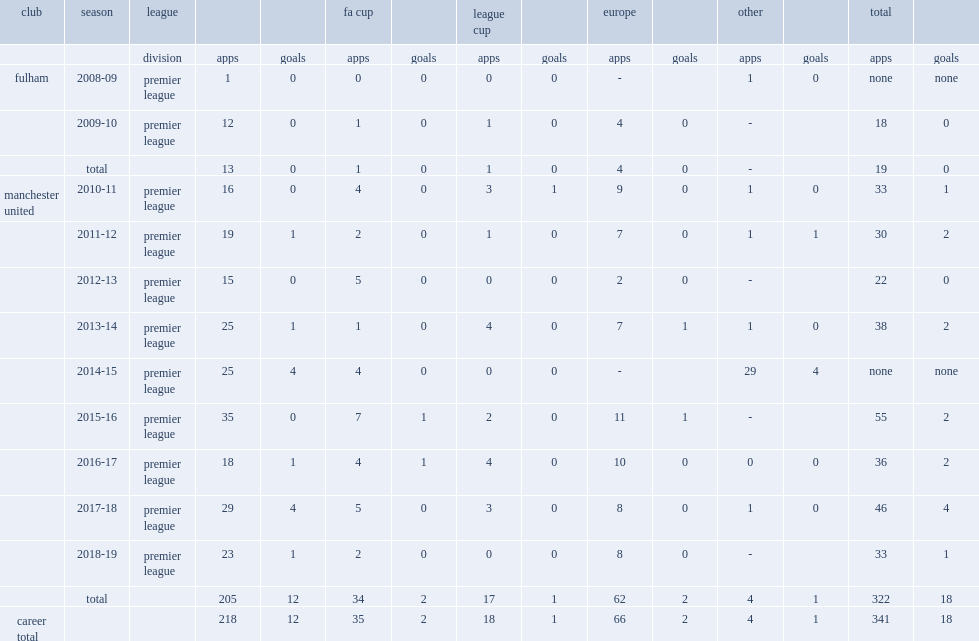Write the full table. {'header': ['club', 'season', 'league', '', '', 'fa cup', '', 'league cup', '', 'europe', '', 'other', '', 'total', ''], 'rows': [['', '', 'division', 'apps', 'goals', 'apps', 'goals', 'apps', 'goals', 'apps', 'goals', 'apps', 'goals', 'apps', 'goals'], ['fulham', '2008-09', 'premier league', '1', '0', '0', '0', '0', '0', '-', '', '1', '0', 'none', 'none'], ['', '2009-10', 'premier league', '12', '0', '1', '0', '1', '0', '4', '0', '-', '', '18', '0'], ['', 'total', '', '13', '0', '1', '0', '1', '0', '4', '0', '-', '', '19', '0'], ['manchester united', '2010-11', 'premier league', '16', '0', '4', '0', '3', '1', '9', '0', '1', '0', '33', '1'], ['', '2011-12', 'premier league', '19', '1', '2', '0', '1', '0', '7', '0', '1', '1', '30', '2'], ['', '2012-13', 'premier league', '15', '0', '5', '0', '0', '0', '2', '0', '-', '', '22', '0'], ['', '2013-14', 'premier league', '25', '1', '1', '0', '4', '0', '7', '1', '1', '0', '38', '2'], ['', '2014-15', 'premier league', '25', '4', '4', '0', '0', '0', '-', '', '29', '4', 'none', 'none'], ['', '2015-16', 'premier league', '35', '0', '7', '1', '2', '0', '11', '1', '-', '', '55', '2'], ['', '2016-17', 'premier league', '18', '1', '4', '1', '4', '0', '10', '0', '0', '0', '36', '2'], ['', '2017-18', 'premier league', '29', '4', '5', '0', '3', '0', '8', '0', '1', '0', '46', '4'], ['', '2018-19', 'premier league', '23', '1', '2', '0', '0', '0', '8', '0', '-', '', '33', '1'], ['', 'total', '', '205', '12', '34', '2', '17', '1', '62', '2', '4', '1', '322', '18'], ['career total', '', '', '218', '12', '35', '2', '18', '1', '66', '2', '4', '1', '341', '18']]} Which club did smalling make his premier league debut for, in the 2008-09 season? Fulham. 